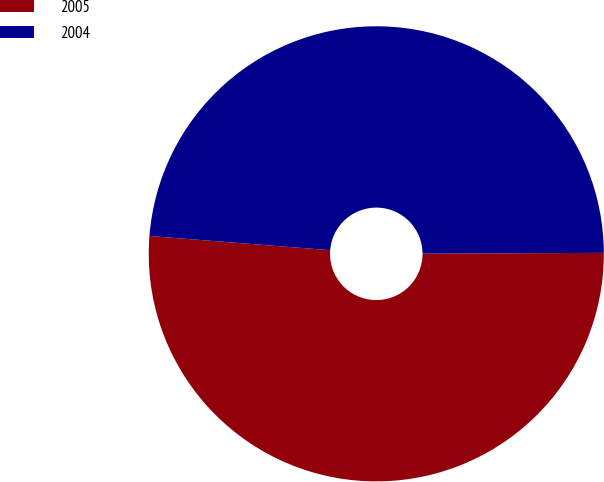Convert chart to OTSL. <chart><loc_0><loc_0><loc_500><loc_500><pie_chart><fcel>2005<fcel>2004<nl><fcel>51.32%<fcel>48.68%<nl></chart> 